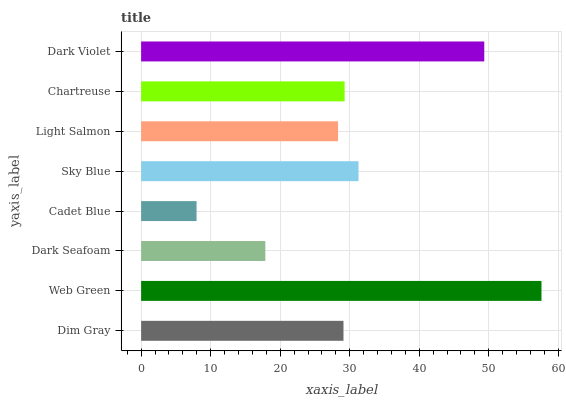Is Cadet Blue the minimum?
Answer yes or no. Yes. Is Web Green the maximum?
Answer yes or no. Yes. Is Dark Seafoam the minimum?
Answer yes or no. No. Is Dark Seafoam the maximum?
Answer yes or no. No. Is Web Green greater than Dark Seafoam?
Answer yes or no. Yes. Is Dark Seafoam less than Web Green?
Answer yes or no. Yes. Is Dark Seafoam greater than Web Green?
Answer yes or no. No. Is Web Green less than Dark Seafoam?
Answer yes or no. No. Is Chartreuse the high median?
Answer yes or no. Yes. Is Dim Gray the low median?
Answer yes or no. Yes. Is Light Salmon the high median?
Answer yes or no. No. Is Dark Violet the low median?
Answer yes or no. No. 